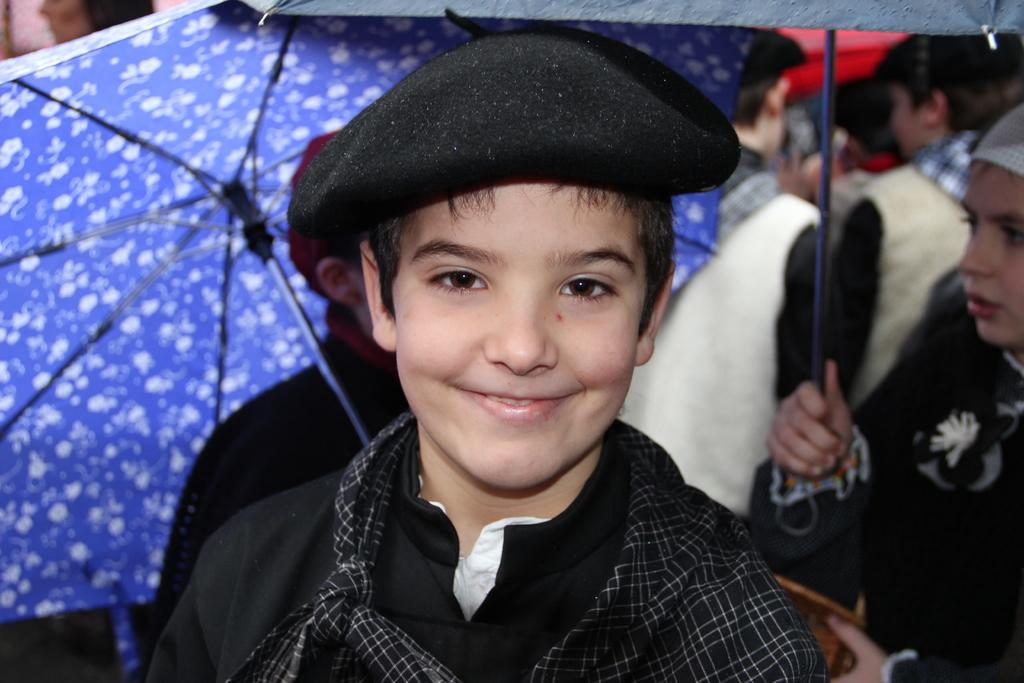How many people are visible in the image? There are many people in the image. What are some people using to protect themselves from the weather? Some people are holding umbrellas. Can you describe the boy in the foreground? In the foreground, a boy is standing. He is wearing a cap and smiling. What type of cake is the boy holding in the image? There is no cake present in the image; the boy is not holding any cake. 